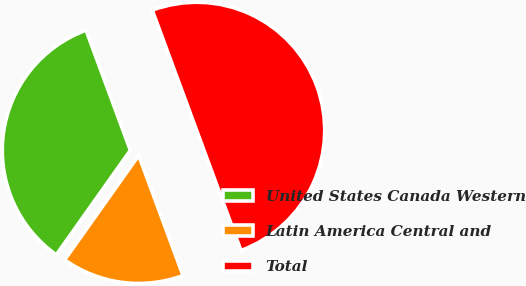Convert chart to OTSL. <chart><loc_0><loc_0><loc_500><loc_500><pie_chart><fcel>United States Canada Western<fcel>Latin America Central and<fcel>Total<nl><fcel>34.56%<fcel>15.44%<fcel>50.0%<nl></chart> 